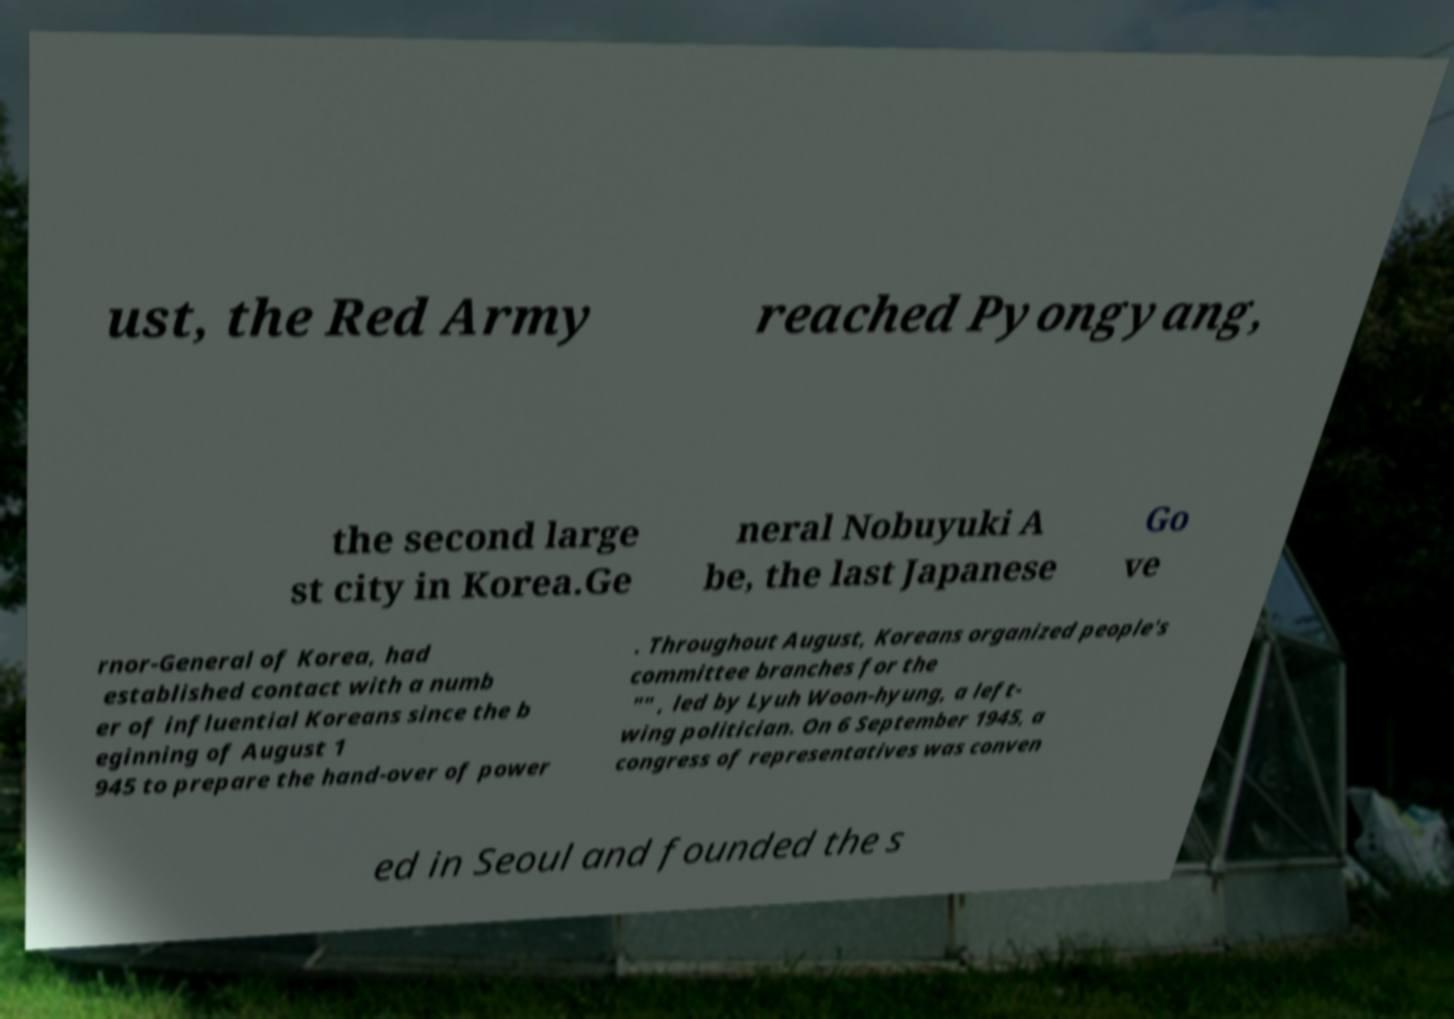Could you assist in decoding the text presented in this image and type it out clearly? ust, the Red Army reached Pyongyang, the second large st city in Korea.Ge neral Nobuyuki A be, the last Japanese Go ve rnor-General of Korea, had established contact with a numb er of influential Koreans since the b eginning of August 1 945 to prepare the hand-over of power . Throughout August, Koreans organized people's committee branches for the "" , led by Lyuh Woon-hyung, a left- wing politician. On 6 September 1945, a congress of representatives was conven ed in Seoul and founded the s 